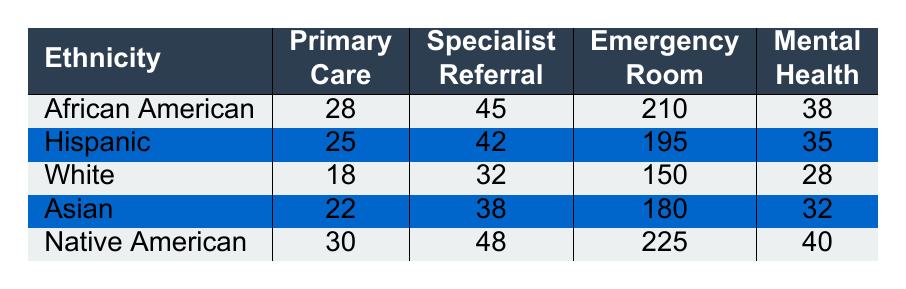What is the wait time for African Americans for a Specialist Referral? According to the table, the wait time for African Americans for a Specialist Referral is 45 minutes.
Answer: 45 minutes Which ethnicity has the longest wait time for an Emergency Room visit? The table shows that Native Americans have the longest wait time for an Emergency Room visit, which is 225 minutes.
Answer: Native American What is the average wait time for Primary Care across all ethnicities? To find the average, we add the Primary Care wait times: 28 + 25 + 18 + 22 + 30 = 123. Dividing by 5 gives an average of 123/5 = 24.6 minutes.
Answer: 24.6 minutes Is the wait time for Mental Health appointments shorter for Whites than for African Americans? The table indicates that the wait time for Whites is 28 minutes and for African Americans it is 38 minutes. Since 28 is less than 38, the statement is true.
Answer: Yes For which appointment type do Asians have the shortest wait time? In the table, for Asians, the wait times for each appointment type are 22 (Primary Care), 38 (Specialist Referral), 180 (Emergency Room), and 32 (Mental Health). The shortest wait time is for Primary Care at 22 minutes.
Answer: Primary Care What is the difference in wait times for Emergency Room visits between African Americans and Hispanics? The wait time for African Americans is 210 minutes and for Hispanics is 195 minutes. The difference is 210 - 195 = 15 minutes.
Answer: 15 minutes Does any ethnicity have a shorter wait time for Specialist Referrals compared to Whites? The Specialist Referral wait time for Whites is 32 minutes. Checking the other ethnicities, African Americans (45), Hispanics (42), Asians (38), and Native Americans (48) all have longer wait times. Thus, the answer is no.
Answer: No What is the overall longest wait time recorded across all ethnicities and appointment types? By reviewing the table, the longest wait time is found under Native Americans for the Emergency Room, which is 225 minutes.
Answer: 225 minutes Which ethnic group has the lowest average wait time across all appointment types? First, we calculate the average for each group: African American (28+45+210+38)/4 = 80.25, Hispanic (25+42+195+35)/4 = 74, White (18+32+150+28)/4 = 57, Asian (22+38+180+32)/4 = 73, Native American (30+48+225+40)/4 = 85.25. The lowest average is for Whites at 57 minutes.
Answer: White What percentage of the total wait time across all appointment types for Native Americans is represented by the wait time for Primary Care? The total wait time for Native Americans is 30 + 48 + 225 + 40 = 343 minutes. The wait time for Primary Care is 30 minutes. The percentage is (30/343) * 100 ≈ 8.75%.
Answer: 8.75% 